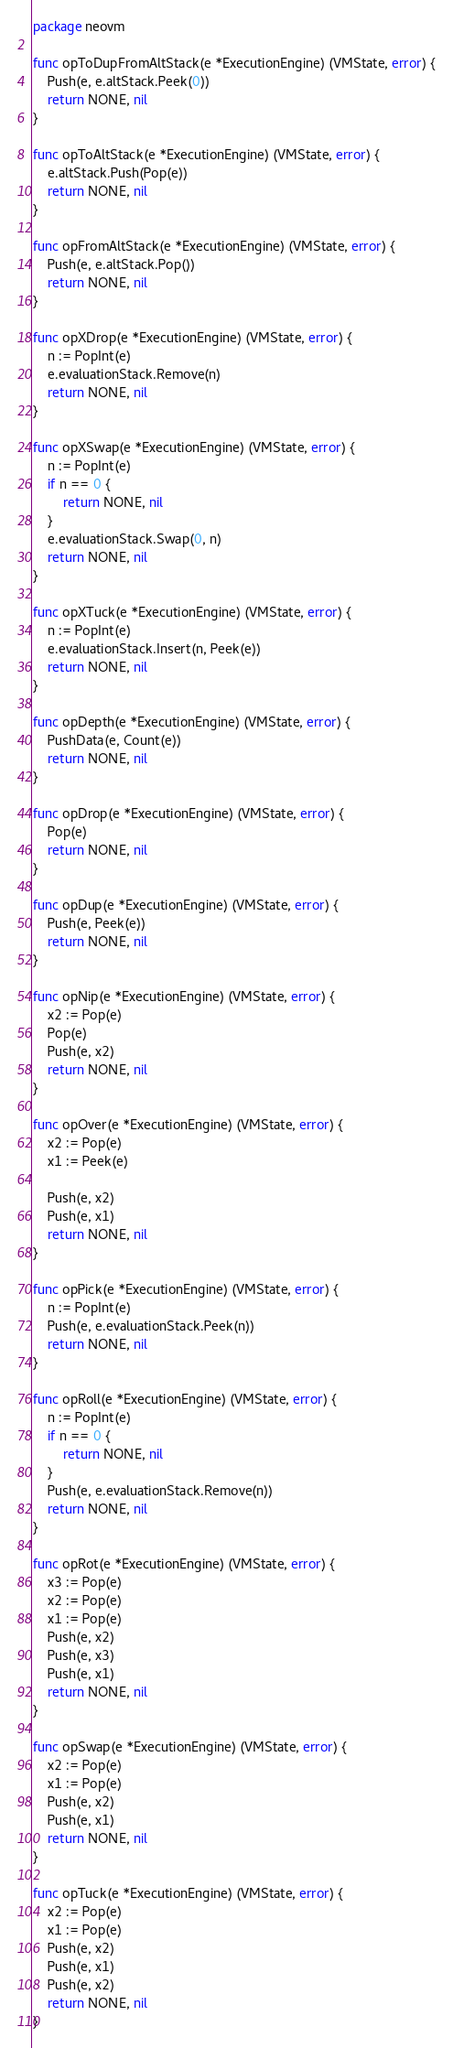Convert code to text. <code><loc_0><loc_0><loc_500><loc_500><_Go_>package neovm

func opToDupFromAltStack(e *ExecutionEngine) (VMState, error) {
	Push(e, e.altStack.Peek(0))
	return NONE, nil
}

func opToAltStack(e *ExecutionEngine) (VMState, error) {
	e.altStack.Push(Pop(e))
	return NONE, nil
}

func opFromAltStack(e *ExecutionEngine) (VMState, error) {
	Push(e, e.altStack.Pop())
	return NONE, nil
}

func opXDrop(e *ExecutionEngine) (VMState, error) {
	n := PopInt(e)
	e.evaluationStack.Remove(n)
	return NONE, nil
}

func opXSwap(e *ExecutionEngine) (VMState, error) {
	n := PopInt(e)
	if n == 0 {
		return NONE, nil
	}
	e.evaluationStack.Swap(0, n)
	return NONE, nil
}

func opXTuck(e *ExecutionEngine) (VMState, error) {
	n := PopInt(e)
	e.evaluationStack.Insert(n, Peek(e))
	return NONE, nil
}

func opDepth(e *ExecutionEngine) (VMState, error) {
	PushData(e, Count(e))
	return NONE, nil
}

func opDrop(e *ExecutionEngine) (VMState, error) {
	Pop(e)
	return NONE, nil
}

func opDup(e *ExecutionEngine) (VMState, error) {
	Push(e, Peek(e))
	return NONE, nil
}

func opNip(e *ExecutionEngine) (VMState, error) {
	x2 := Pop(e)
	Pop(e)
	Push(e, x2)
	return NONE, nil
}

func opOver(e *ExecutionEngine) (VMState, error) {
	x2 := Pop(e)
	x1 := Peek(e)

	Push(e, x2)
	Push(e, x1)
	return NONE, nil
}

func opPick(e *ExecutionEngine) (VMState, error) {
	n := PopInt(e)
	Push(e, e.evaluationStack.Peek(n))
	return NONE, nil
}

func opRoll(e *ExecutionEngine) (VMState, error) {
	n := PopInt(e)
	if n == 0 {
		return NONE, nil
	}
	Push(e, e.evaluationStack.Remove(n))
	return NONE, nil
}

func opRot(e *ExecutionEngine) (VMState, error) {
	x3 := Pop(e)
	x2 := Pop(e)
	x1 := Pop(e)
	Push(e, x2)
	Push(e, x3)
	Push(e, x1)
	return NONE, nil
}

func opSwap(e *ExecutionEngine) (VMState, error) {
	x2 := Pop(e)
	x1 := Pop(e)
	Push(e, x2)
	Push(e, x1)
	return NONE, nil
}

func opTuck(e *ExecutionEngine) (VMState, error) {
	x2 := Pop(e)
	x1 := Pop(e)
	Push(e, x2)
	Push(e, x1)
	Push(e, x2)
	return NONE, nil
}

</code> 